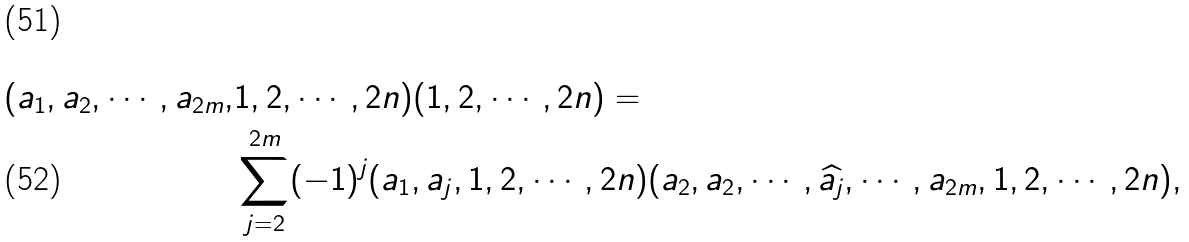Convert formula to latex. <formula><loc_0><loc_0><loc_500><loc_500>( a _ { 1 } , a _ { 2 } , \cdots , a _ { 2 m } , & 1 , 2 , \cdots , 2 n ) ( 1 , 2 , \cdots , 2 n ) = \\ & \sum _ { j = 2 } ^ { 2 m } ( - 1 ) ^ { j } ( a _ { 1 } , a _ { j } , 1 , 2 , \cdots , 2 n ) ( a _ { 2 } , a _ { 2 } , \cdots , \widehat { a _ { j } } , \cdots , a _ { 2 m } , 1 , 2 , \cdots , 2 n ) ,</formula> 